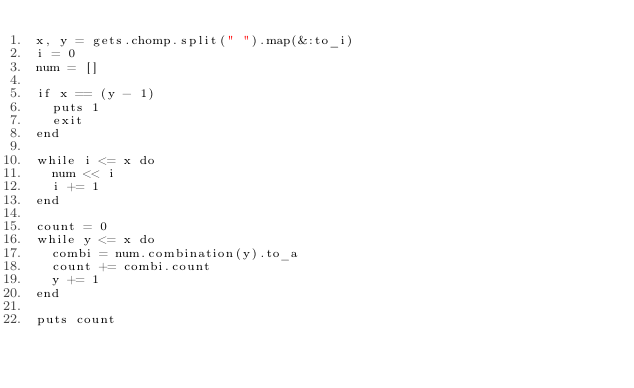Convert code to text. <code><loc_0><loc_0><loc_500><loc_500><_Ruby_>x, y = gets.chomp.split(" ").map(&:to_i)
i = 0
num = []

if x == (y - 1)
  puts 1
  exit
end

while i <= x do
  num << i
  i += 1
end

count = 0
while y <= x do
  combi = num.combination(y).to_a
  count += combi.count
  y += 1
end

puts count
</code> 